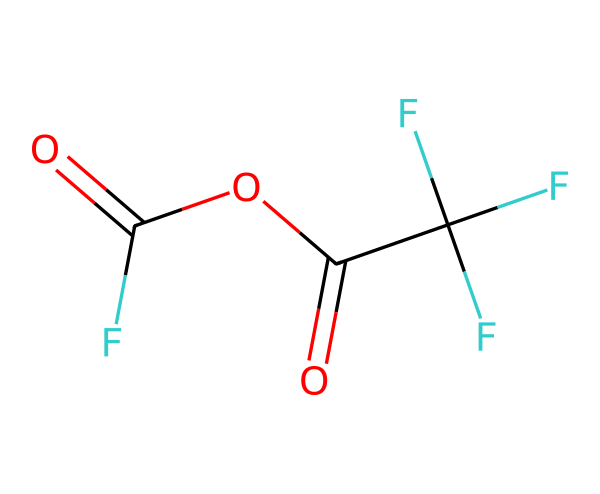What is the total number of carbon atoms in trifluoroacetic anhydride? By analyzing the SMILES representation, we can see 'C' appears three times, which indicates three carbon atoms present in the molecule.
Answer: three How many fluorine atoms are in trifluoroacetic anhydride? The SMILES notation contains 'F' three times, showing that there are three fluorine atoms present in the molecule.
Answer: three What is the general formula for the acid anhydrides? Acid anhydrides generally have the formula RCO(OCR') where R and R' are hydrocarbon groups; in this case, it can be derived from the structure in the SMILES.
Answer: RCO(OCR') Which functional groups are present in trifluoroacetic anhydride? The molecule contains carbonyl (C=O) and ester (RCOOR') functional groups represented in the structure.
Answer: carbonyl and ester What type of reaction does trifluoroacetic anhydride typically participate in as a dehydrating agent? Trifluoroacetic anhydride is commonly used in condensation reactions where it removes a molecule of water during the bonding of two molecules, emphasizing its role as a dehydrating agent.
Answer: condensation reaction Which part of the trifluoroacetic anhydride structure contributes to its high reactivity? The presence of the three highly electronegative fluorine atoms significantly increases the reactivity of the acid anhydride by making the carbonyl carbon more susceptible to nucleophilic attack due to the strong electron-withdrawing effect of fluorine.
Answer: carbonyl carbon What is the significance of the anhydride linkage in trifluoroacetic anhydride? The anhydride linkage (RCO-O-CR') in trifluoroacetic anhydride plays a crucial role in its ability to donate acyl groups in acylation reactions, which is fundamental in various organic synthesis pathways.
Answer: acylation reactions 